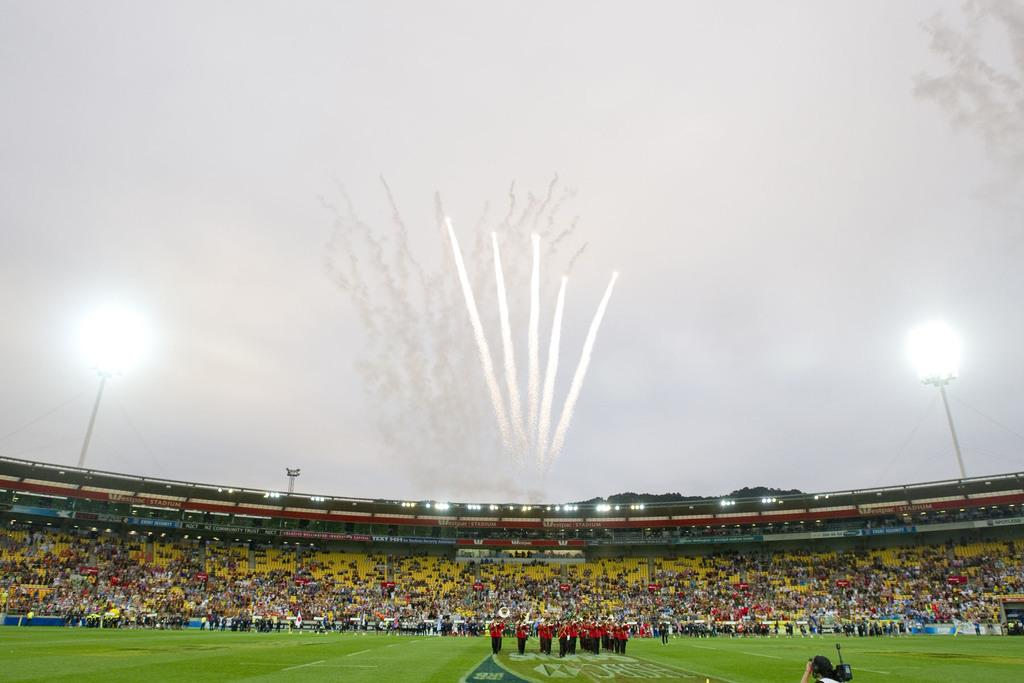What is the setting of the image? People are present in a stadium. What can be seen in the image besides the people? There are lights visible in the image. What is happening in the sky in the image? Fireworks are present in the sky. What type of toy can be seen being played with by the people in the image? There is no toy present in the image; people are in a stadium, and fireworks are visible in the sky. 